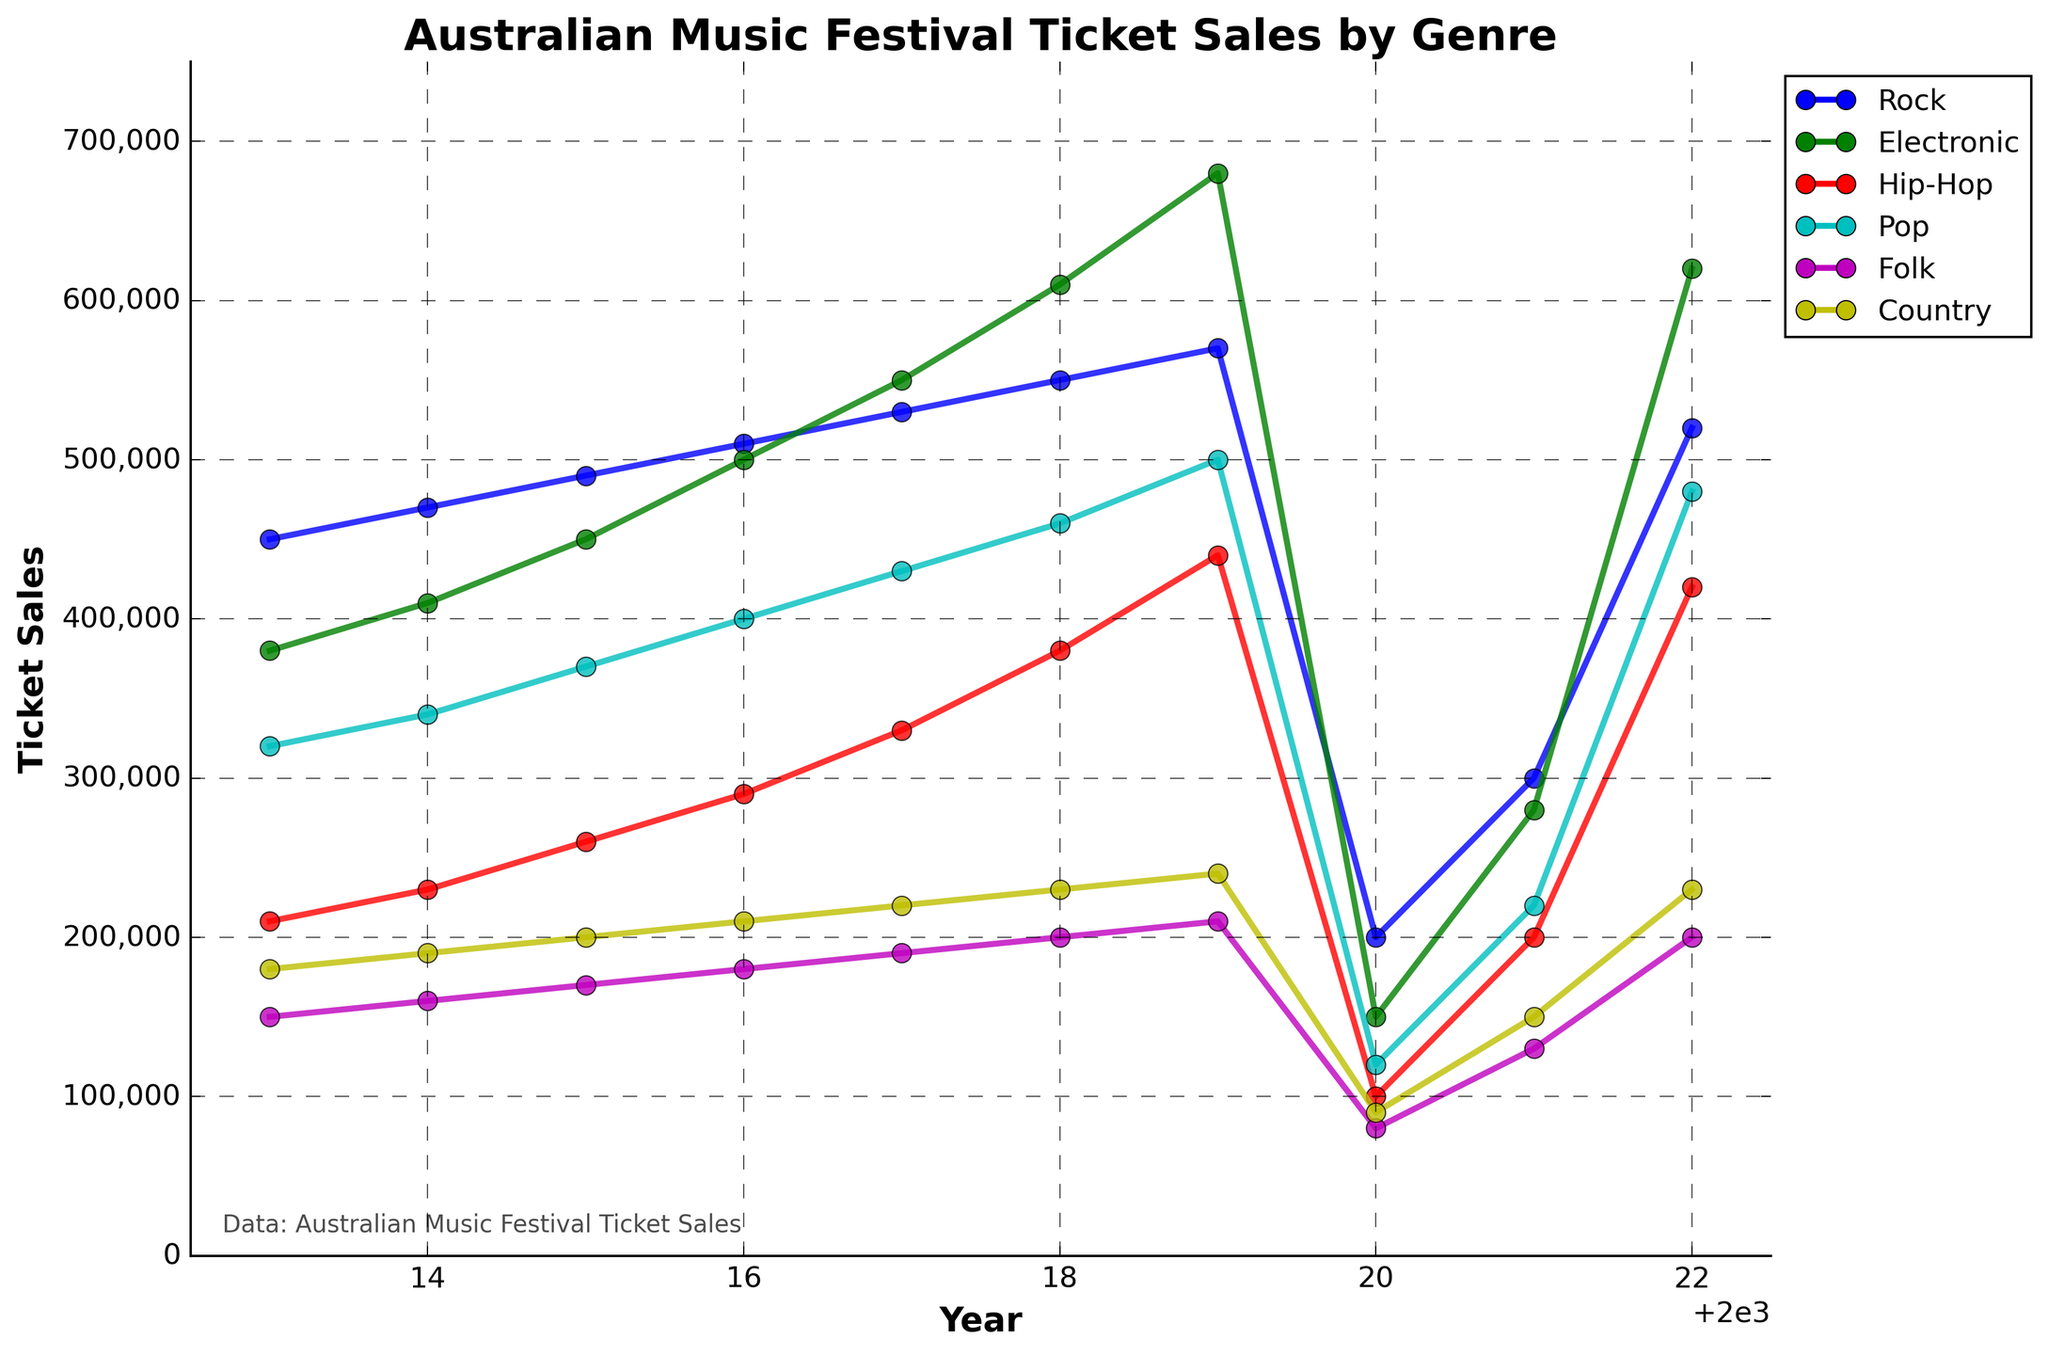What genre showed the highest ticket sales in 2019? To find the genre with the highest ticket sales in 2019, locate the highest point among all genres for the year 2019. Based on the plot lines, the ticket sales for Electronic music are at the highest point.
Answer: Electronic Which genre had the steepest increase in ticket sales from 2014 to 2015? To determine which genre had the steepest increase, look at the slopes of the lines between the years 2014 and 2015. The line with the steepest upward slope is for Electronic music.
Answer: Electronic What was the overall trend in ticket sales for Rock music from 2013 to 2022? Observe the overall direction of the Rock genre line from 2013 to 2022. It shows an upward trend with a dip in 2020 and subsequent recovery in 2021 and 2022.
Answer: Upward trend Comparing Pop and Country music, which genre had more consistent ticket sales over the decade? Consistent ticket sales can be seen in a line with less variation year to year. The Pop genre has a relatively stable line compared to the more variable Country music line.
Answer: Pop What is the average ticket sales for Folk music over the decade? Sum the ticket sales numbers for Folk music from 2013 to 2022 and divide by the number of years (10). (150,000 + 160,000 + 170,000 + 180,000 + 190,000 + 200,000 + 210,000 + 80,000 + 130,000 + 200,000) / 10 = 167,000
Answer: 167,000 Which genre experienced the largest drop in ticket sales from 2019 to 2020? Identify the genre with the biggest difference in ticket sales between 2019 and 2020. The largest drop is in Electronic music, declining from 680,000 to 150,000.
Answer: Electronic How did Hip-Hop ticket sales in 2022 compare to those in 2018? Compare the ticket sales values for Hip-Hop music in 2018 and 2022. In 2018, the ticket sales were 380,000, while in 2022, they were 420,000.
Answer: Higher in 2022 Which genre had the smallest increase in ticket sales from 2013 to 2018? Calculate the difference in ticket sales from 2013 to 2018 for each genre and identify the one with the smallest increase. For Rock: 550,000 - 450,000 = 100,000; for Electronic: 610,000 - 380,000 = 230,000; for Hip-Hop: 380,000 - 210,000 = 170,000; for Pop: 460,000 - 320,000 = 140,000; for Folk: 200,000 - 150,000 = 50,000; for Country: 230,000 - 180,000 = 50,000. Folk and Country both have the smallest increase of 50,000.
Answer: Folk and Country Which genre's ticket sales recovered the most from 2020 to 2021? Find the difference in ticket sales between 2020 and 2021 for each genre and determine which has the largest increase. (Rock: 300,000-200,000=100,000, Electronic: 280,000-150,000=130,000, Hip-Hop: 200,000-100,000=100,000, Pop: 220,000-120,000=100,000, Folk: 130,000-80,000=50,000, Country: 150,000-90,000=60,000)
Answer: Electronic 